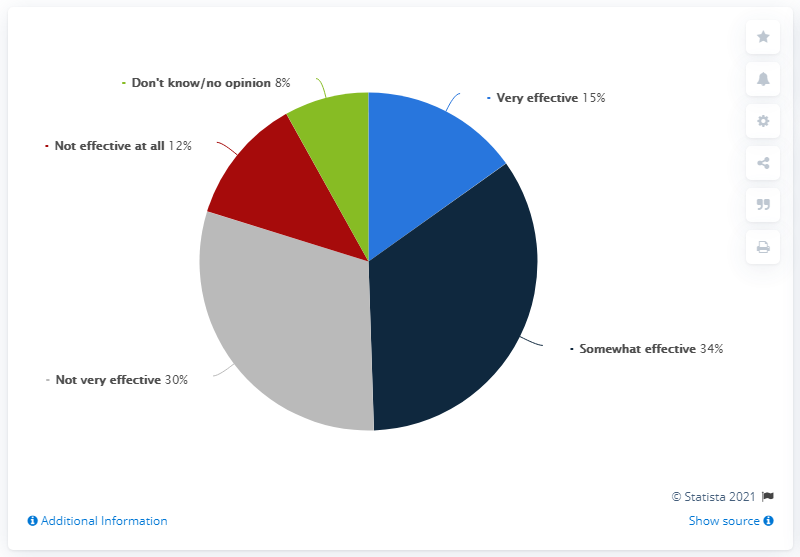Highlight a few significant elements in this photo. The sum of the least opinion and the median opinion is 23. The gray segment occupies only a small fraction in the pie chart, which is not very effective in conveying the data. 